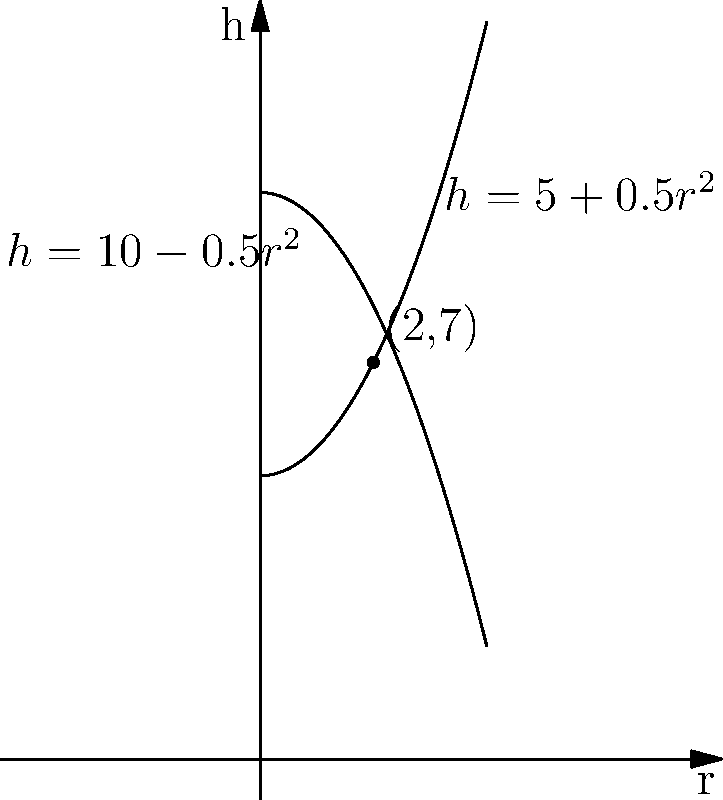A baby bottle manufacturer wants to design a new cylindrical bottle. The height (h) and radius (r) of the bottle are related by two functions: $h = 5 + 0.5r^2$ and $h = 10 - 0.5r^2$, where h and r are measured in centimeters. At what volume (in cubic centimeters) do these two functions intersect? Let's approach this step-by-step:

1) First, we need to find the point of intersection. This occurs when:
   $5 + 0.5r^2 = 10 - 0.5r^2$

2) Solving this equation:
   $5 + 0.5r^2 = 10 - 0.5r^2$
   $r^2 = 5$
   $r = \sqrt{5} = 2.236$ cm (we'll keep more decimal places for accuracy)

3) We can find h by plugging this r value into either equation:
   $h = 5 + 0.5(2.236)^2 = 7.5$ cm

4) Now we have the radius and height of the cylinder at the intersection point. To find the volume, we use the formula for the volume of a cylinder:
   $V = \pi r^2 h$

5) Plugging in our values:
   $V = \pi (2.236)^2 (7.5)$
   $V = \pi (5) (7.5)$
   $V = 37.5\pi$ cubic centimeters

6) Calculating this:
   $V \approx 117.81$ cubic centimeters

Therefore, the volume at the intersection point is approximately 117.81 cubic centimeters.
Answer: 117.81 cm³ 